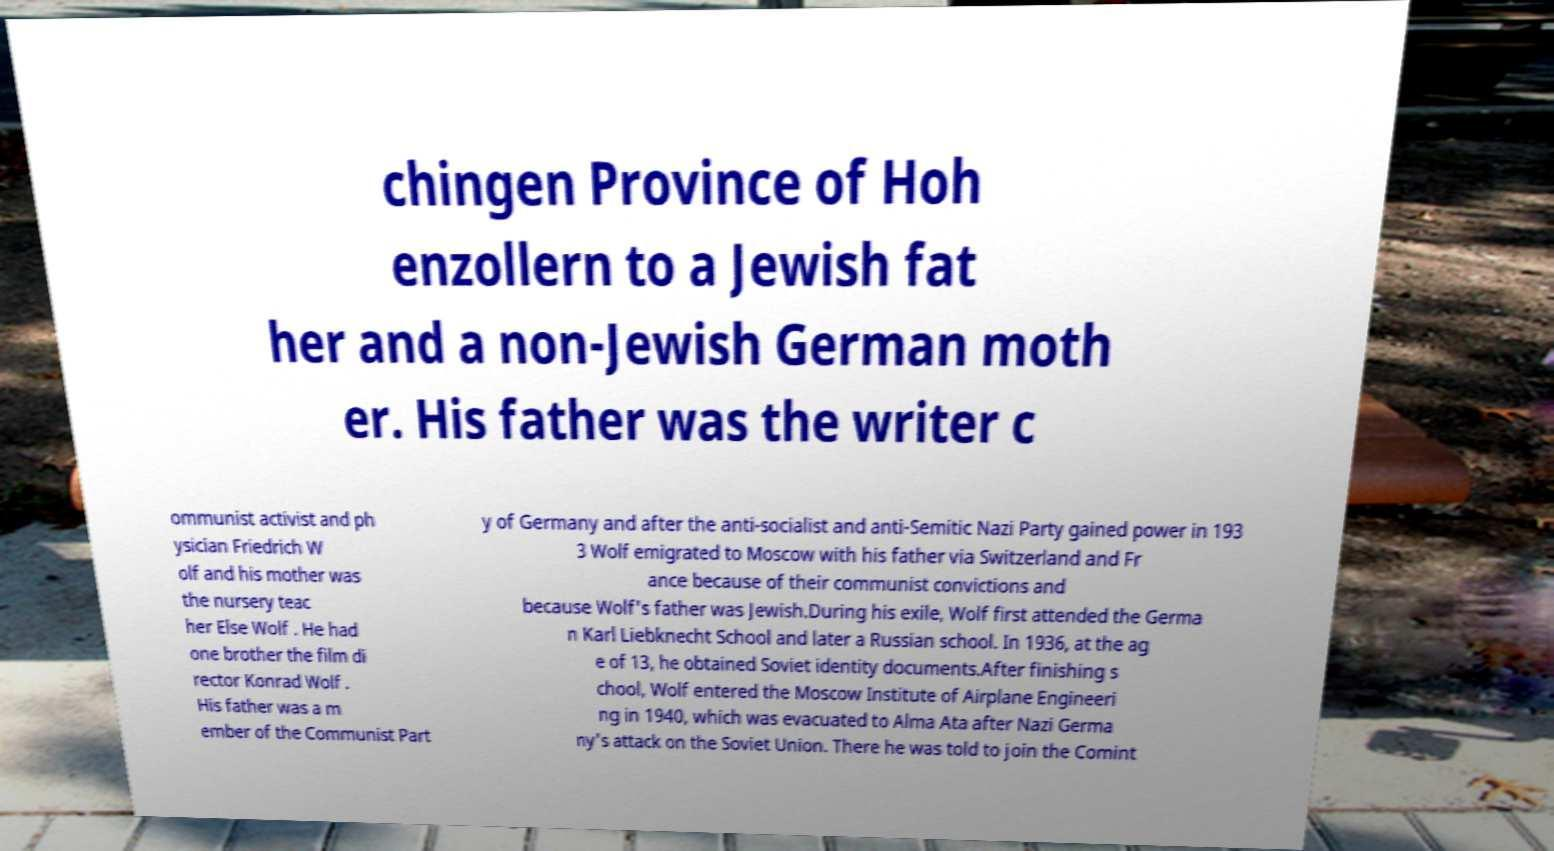There's text embedded in this image that I need extracted. Can you transcribe it verbatim? chingen Province of Hoh enzollern to a Jewish fat her and a non-Jewish German moth er. His father was the writer c ommunist activist and ph ysician Friedrich W olf and his mother was the nursery teac her Else Wolf . He had one brother the film di rector Konrad Wolf . His father was a m ember of the Communist Part y of Germany and after the anti-socialist and anti-Semitic Nazi Party gained power in 193 3 Wolf emigrated to Moscow with his father via Switzerland and Fr ance because of their communist convictions and because Wolf's father was Jewish.During his exile, Wolf first attended the Germa n Karl Liebknecht School and later a Russian school. In 1936, at the ag e of 13, he obtained Soviet identity documents.After finishing s chool, Wolf entered the Moscow Institute of Airplane Engineeri ng in 1940, which was evacuated to Alma Ata after Nazi Germa ny's attack on the Soviet Union. There he was told to join the Comint 